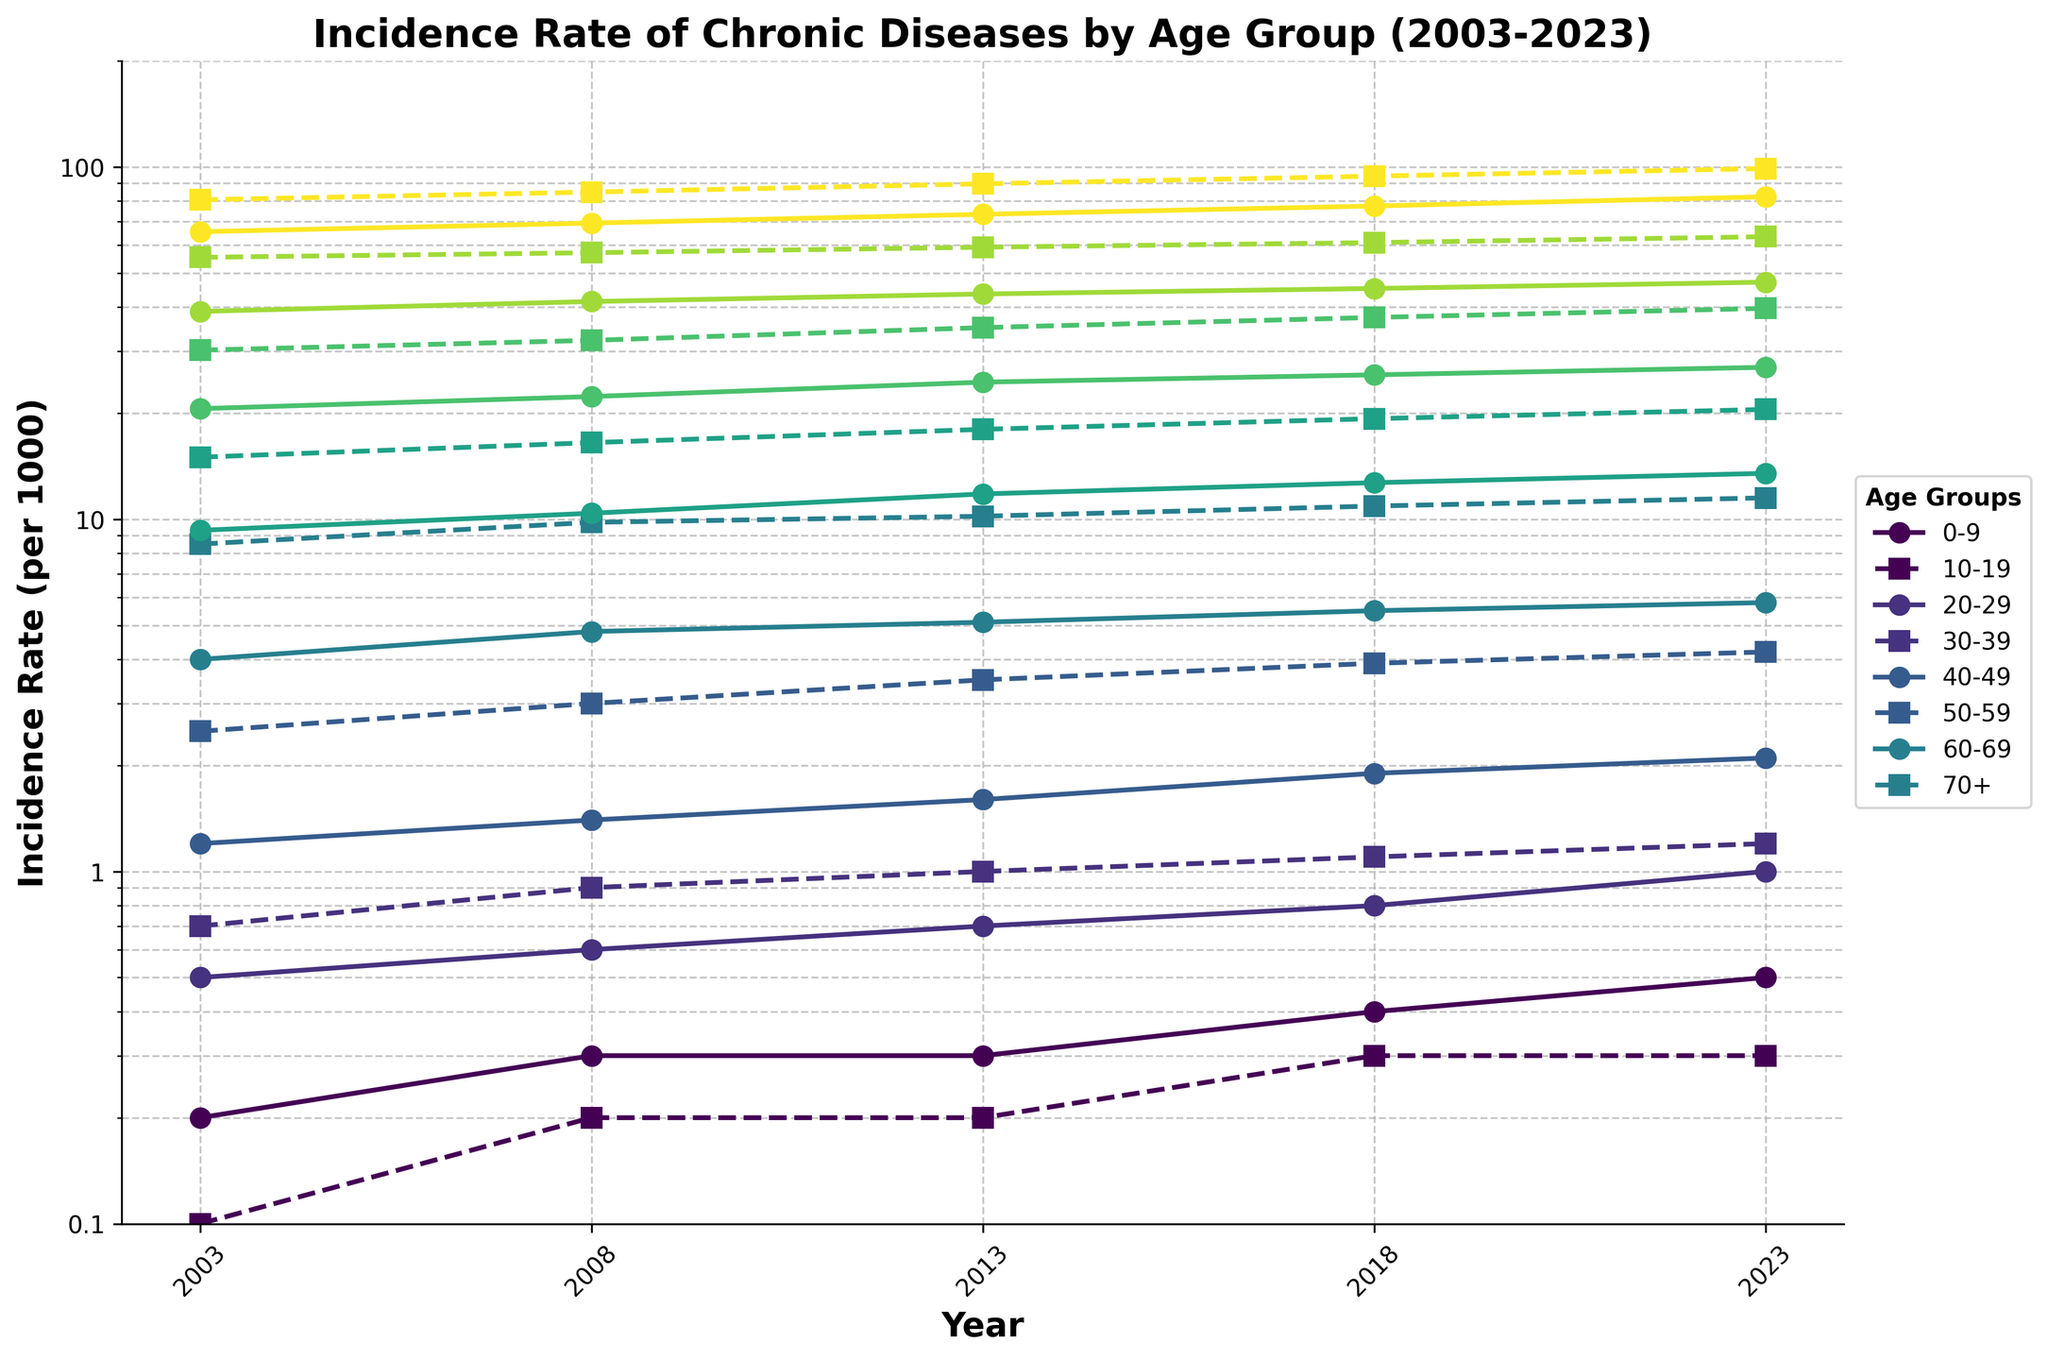what is the title of the plot? The title is located at the top of the plot and provides an overview of the data being displayed. Here, the title is "Incidence Rate of Chronic Diseases by Age Group (2003-2023)."
Answer: Incidence Rate of Chronic Diseases by Age Group (2003-2023) What's displayed on the x-axis and y-axis? The x-axis displays the year and marks several specific years from 2003 to 2023. The y-axis displays the incidence rate per 1000 individuals on a logarithmic scale.
Answer: x-axis: Year, y-axis: Incidence Rate (per 1000) What age group had the highest incidence rate of diabetes in 2023? The lines and markers on the plot use different colors for each age group. The plot has both solid lines (for diabetes) and dashed lines (for hypertension). The highest solid line in 2023 corresponds to the '70+' age group.
Answer: 70+ Which chronic disease had a higher incidence rate for the age group 30-39 in 2003? Looking at the lines for the 30-39 age group, the solid line (diabetes) and dashed line (hypertension) intersect on the plot. In 2003, the incidence rate for hypertension (dashed line) is higher.
Answer: Hypertension Did the incidence rate of diabetes for the age group 20-29 increase or decrease from 2003 to 2023? Trace the solid line for the 20-29 age group from 2003 to 2023. The solid line shows an upward trend, indicating an increase in the incidence rate of diabetes.
Answer: Increase Between 2008 and 2018, which age group had the largest increase in the hypertension incidence rate? By comparing the slope of the dashed lines between 2008 and 2018 for all age groups, the steepest line corresponds to the '70+' age group.
Answer: 70+ How many age groups are compared in the plot? The legend at the side of the plot shows different colors and labels for each age group. Counting these labels, there are 8 different age groups.
Answer: 8 What is the range of the incidence rate for diabetes in the age group 40-49 across the years? Observe the solid line for the 40-49 age group and note the lowest and highest points on the y-axis between 2003 and 2023. The range is from 9.3 to 13.5 per 1000.
Answer: 9.3 to 13.5 per 1000 Which age group had the smallest increase in diabetes incidence rate over the 20 years? Comparing the difference between the starting and ending points of the solid lines for each age group, the 0-9 age group shows the smallest change.
Answer: 0-9 